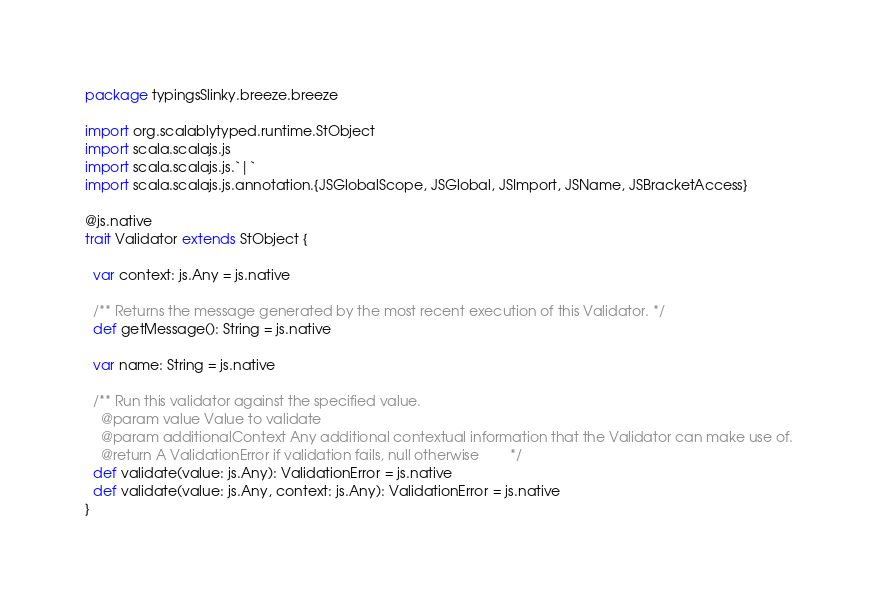Convert code to text. <code><loc_0><loc_0><loc_500><loc_500><_Scala_>package typingsSlinky.breeze.breeze

import org.scalablytyped.runtime.StObject
import scala.scalajs.js
import scala.scalajs.js.`|`
import scala.scalajs.js.annotation.{JSGlobalScope, JSGlobal, JSImport, JSName, JSBracketAccess}

@js.native
trait Validator extends StObject {
  
  var context: js.Any = js.native
  
  /** Returns the message generated by the most recent execution of this Validator. */
  def getMessage(): String = js.native
  
  var name: String = js.native
  
  /** Run this validator against the specified value.
    @param value Value to validate
    @param additionalContext Any additional contextual information that the Validator can make use of.
    @return A ValidationError if validation fails, null otherwise        */
  def validate(value: js.Any): ValidationError = js.native
  def validate(value: js.Any, context: js.Any): ValidationError = js.native
}
</code> 